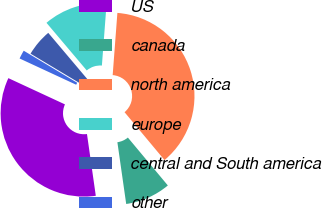Convert chart to OTSL. <chart><loc_0><loc_0><loc_500><loc_500><pie_chart><fcel>US<fcel>canada<fcel>north america<fcel>europe<fcel>central and South america<fcel>other<nl><fcel>34.17%<fcel>8.81%<fcel>37.73%<fcel>12.37%<fcel>5.24%<fcel>1.68%<nl></chart> 